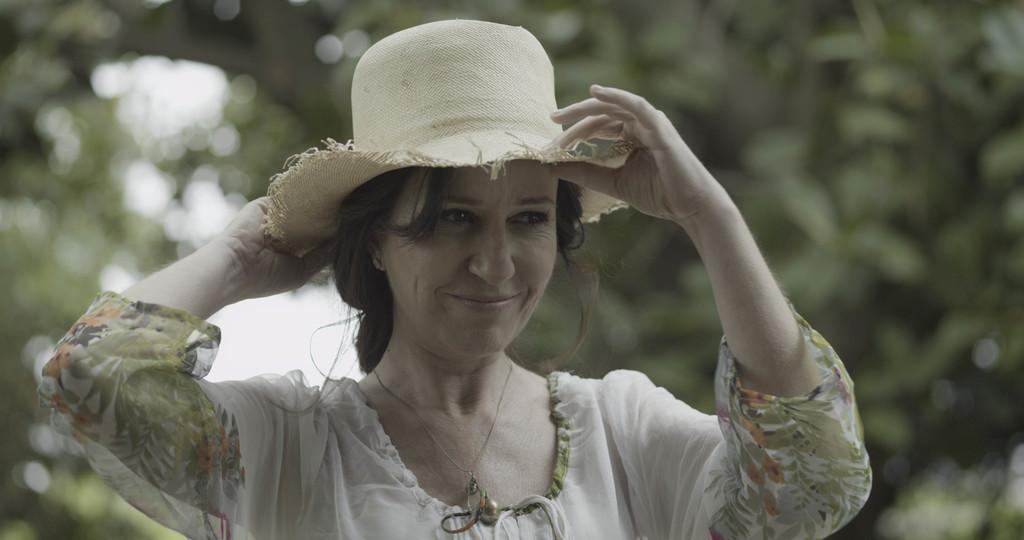Who is the main subject in the image? There is a woman in the image. What is the woman doing in the image? The woman is adjusting her hat. What is the woman wearing in the image? The woman is wearing a white dress. What is the woman's facial expression in the image? The woman is smiling. What type of thread is being used to sew the woman's hat in the image? There is no thread visible in the image, and the woman is adjusting her hat, not sewing it. 